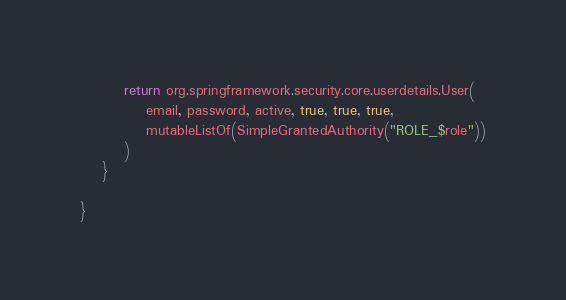Convert code to text. <code><loc_0><loc_0><loc_500><loc_500><_Kotlin_>        return org.springframework.security.core.userdetails.User(
            email, password, active, true, true, true,
            mutableListOf(SimpleGrantedAuthority("ROLE_$role"))
        )
    }

}
</code> 